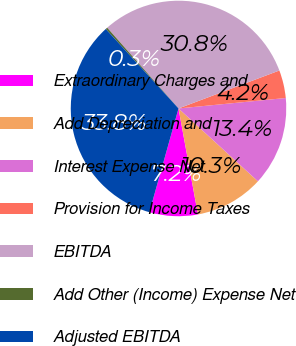<chart> <loc_0><loc_0><loc_500><loc_500><pie_chart><fcel>Extraordinary Charges and<fcel>Add Depreciation and<fcel>Interest Expense Net<fcel>Provision for Income Taxes<fcel>EBITDA<fcel>Add Other (Income) Expense Net<fcel>Adjusted EBITDA<nl><fcel>7.24%<fcel>10.3%<fcel>13.36%<fcel>4.18%<fcel>30.78%<fcel>0.28%<fcel>33.84%<nl></chart> 